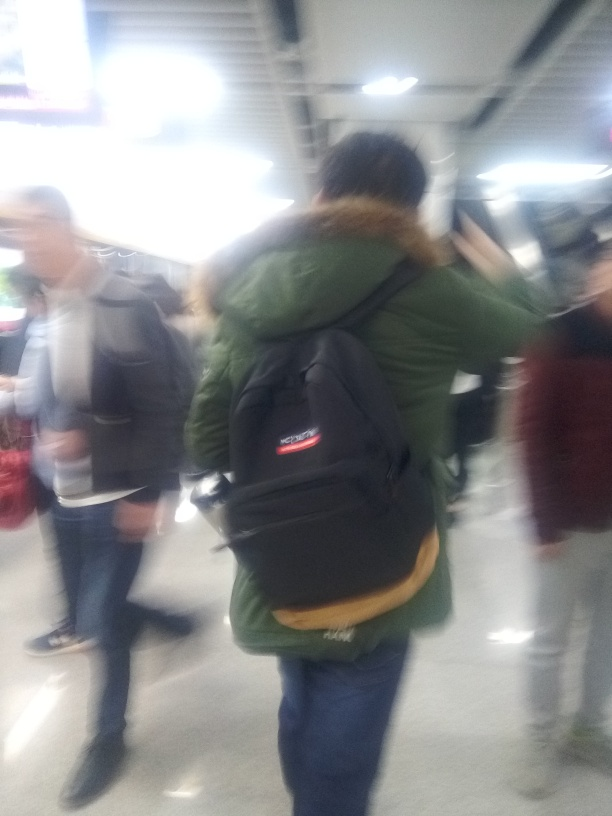Does this image appear to be taken intentionally or by accident? The image seems to have been taken unintentionally or in haste. The blur and composition suggest that the photographer may have been moving or not focused on creating a composed image, indicative of an accidental or spur-of-the-moment picture. 